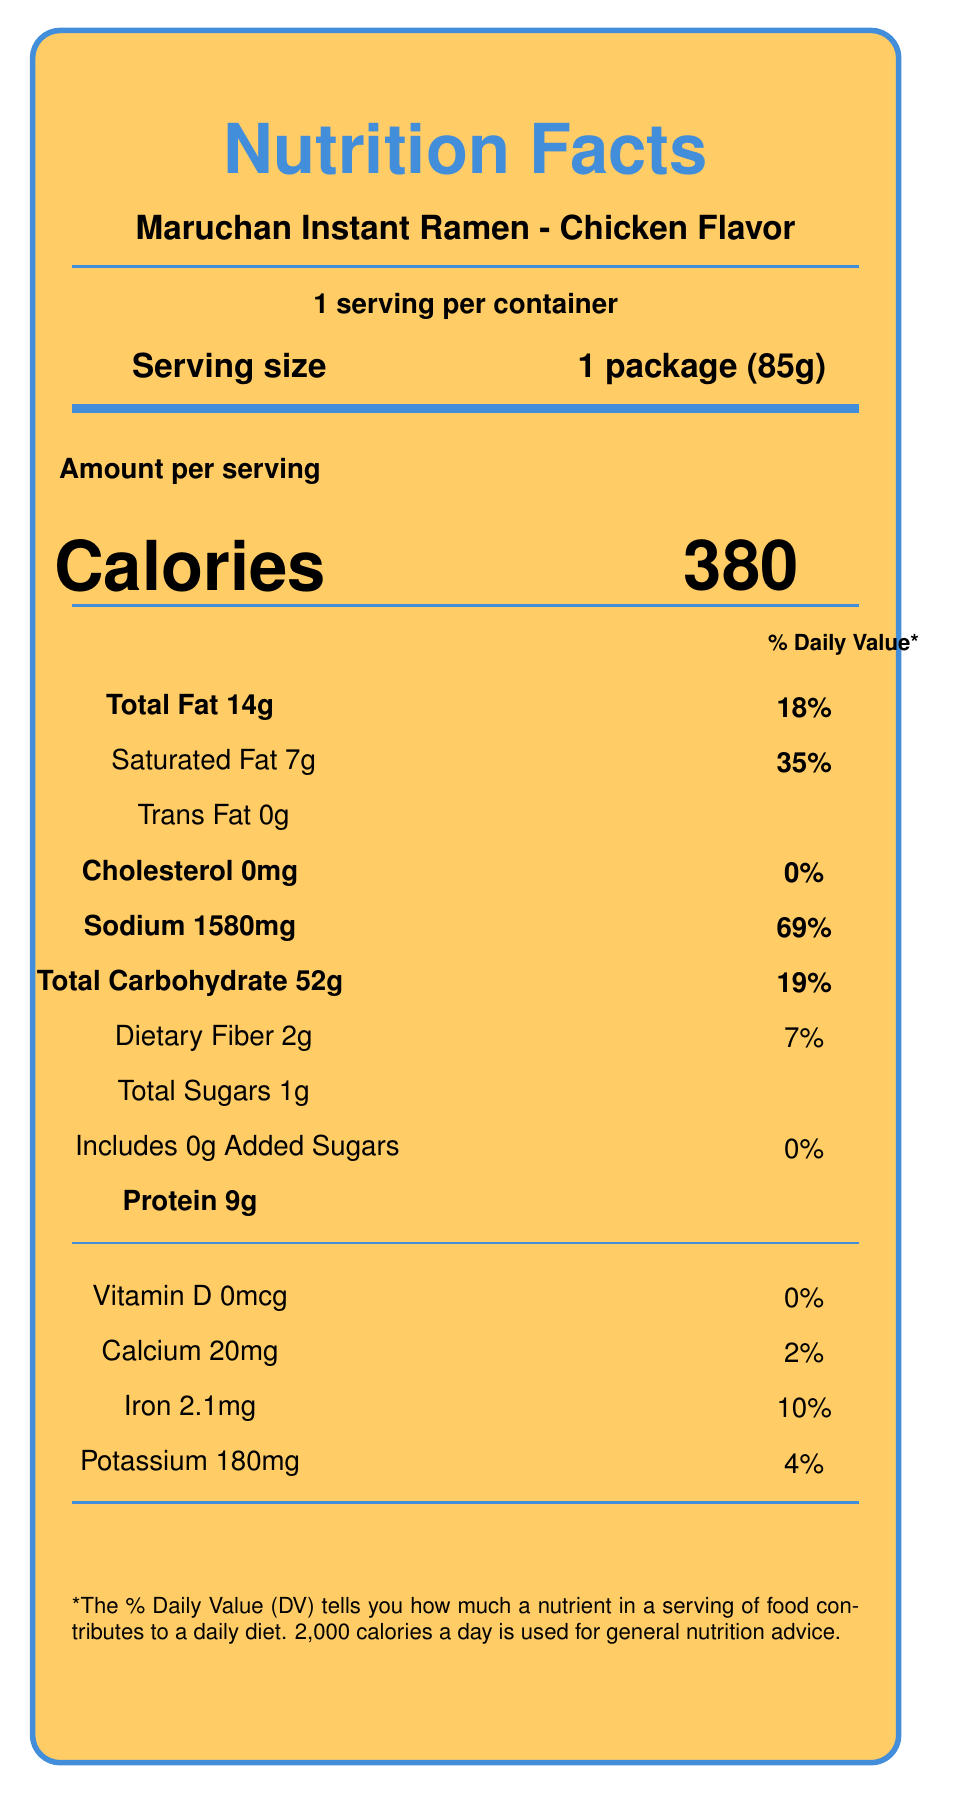What is the serving size of Maruchan Instant Ramen - Chicken Flavor? The document explicitly lists the serving size as "1 package (85g)".
Answer: 1 package (85g) How many calories are in one serving of Maruchan Instant Ramen - Chicken Flavor? The document states that each serving contains 380 calories.
Answer: 380 What percentage of the daily value of sodium does one serving provide? The document shows that the sodium content for one serving is 1580mg, which is 69% of the daily value.
Answer: 69% How much total fat is in one serving? The document mentions that the total fat per serving is 14 grams.
Answer: 14g Does the instant ramen contain any trans fat? Under the "Trans Fat" section, the amount is listed as 0g.
Answer: No What is the total carbohydrate content per serving? The document lists the total carbohydrate content per serving as 52 grams.
Answer: 52g Which of the following nutrients does instant ramen contain the least of? A. Calcium B. Iron C. Potassium D. Dietary Fiber The document lists Calcium as 20mg (2%), which is the lowest amount compared to Iron (2.1mg, 10%), Potassium (180mg, 4%), and Dietary Fiber (2g, 7%).
Answer: A. Calcium Which of these health characteristics is true for Maruchan Instant Ramen - Chicken Flavor? A. High in dietary fiber B. Low in sodium C. Contains no added sugars D. High in protein The document shows that added sugars are listed as 0g.
Answer: C. Contains no added sugars Is the instant ramen a good source of protein? Although it contains 9g of protein, this would not be considered a high source based on daily nutritional standards.
Answer: No Summarize the nutritional information provided for Maruchan Instant Ramen - Chicken Flavor. This document provides a detailed nutritional breakdown of Maruchan Instant Ramen - Chicken Flavor, specifying the amounts and daily values for various nutrients per serving. The key nutritional values include 380 calories, 14g total fat (18% DV), 7g saturated fat (35% DV), 0g trans fat, 0mg cholesterol (0% DV), 1580mg sodium (69% DV), 52g total carbohydrate (19% DV), 2g dietary fiber (7% DV), 1g total sugars with 0g added sugars, and 9g protein. It also includes vitamin D, calcium, iron, and potassium information, along with a note on daily value percentages based on a 2,000 calorie diet. What is the pictorial representation typically shown alongside ramen in slice-of-life manga as mentioned in the document? This is detailed in the "manga_context" section, describing how instant ramen is depicted in manga.
Answer: Steam rising from the bowl, chopsticks, and a character slurping noodles Can you determine the exact price of Maruchan Instant Ramen - Chicken Flavor from this document? The document does not provide any pricing information for the product.
Answer: Not enough information 